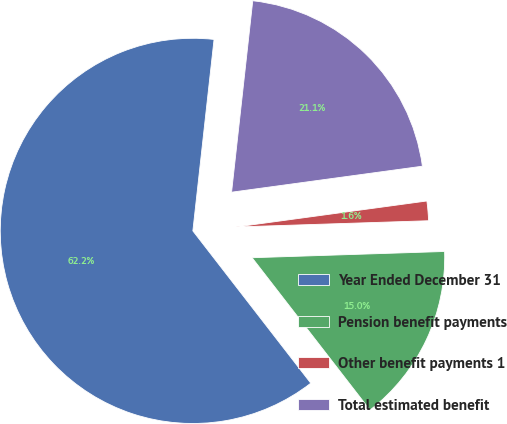<chart> <loc_0><loc_0><loc_500><loc_500><pie_chart><fcel>Year Ended December 31<fcel>Pension benefit payments<fcel>Other benefit payments 1<fcel>Total estimated benefit<nl><fcel>62.24%<fcel>15.03%<fcel>1.64%<fcel>21.09%<nl></chart> 